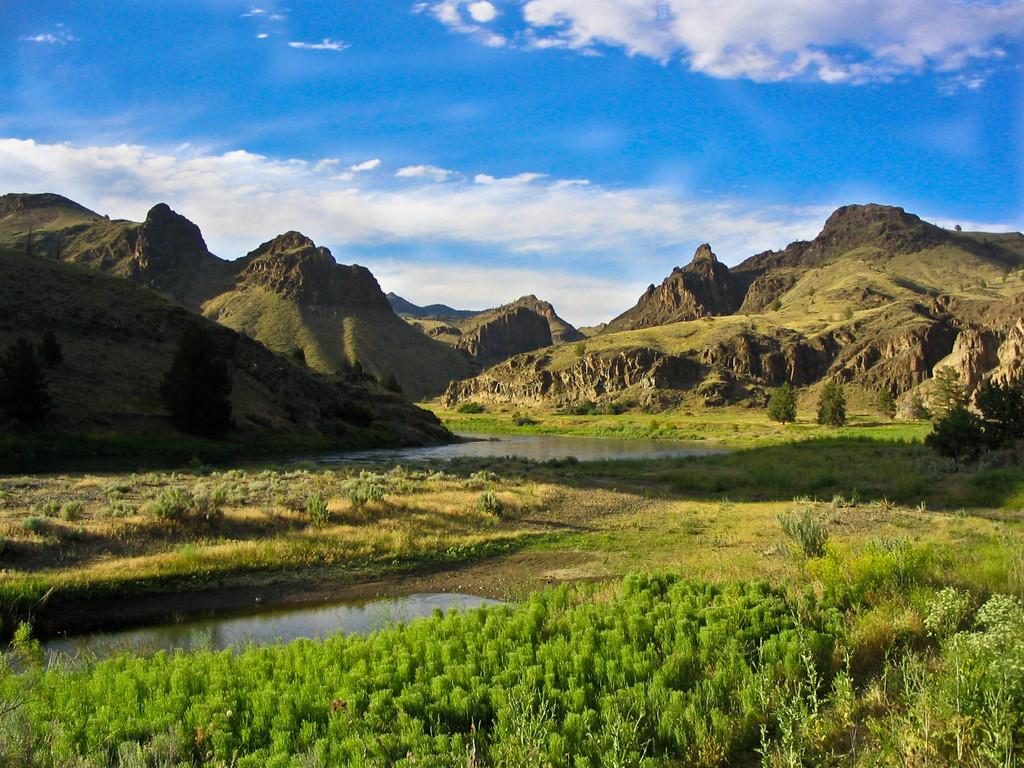What type of landscape is depicted in the image? The image features hills. What can be found at the bottom of the hills? There is grass and plants at the bottom of the image. What natural element is visible in the image? Water is visible in the image. What can be seen in the background of the image? The sky is visible in the background of the image. What type of acoustics can be heard in the scene depicted in the image? There is no sound or acoustics mentioned or depicted in the image, so it cannot be determined. 